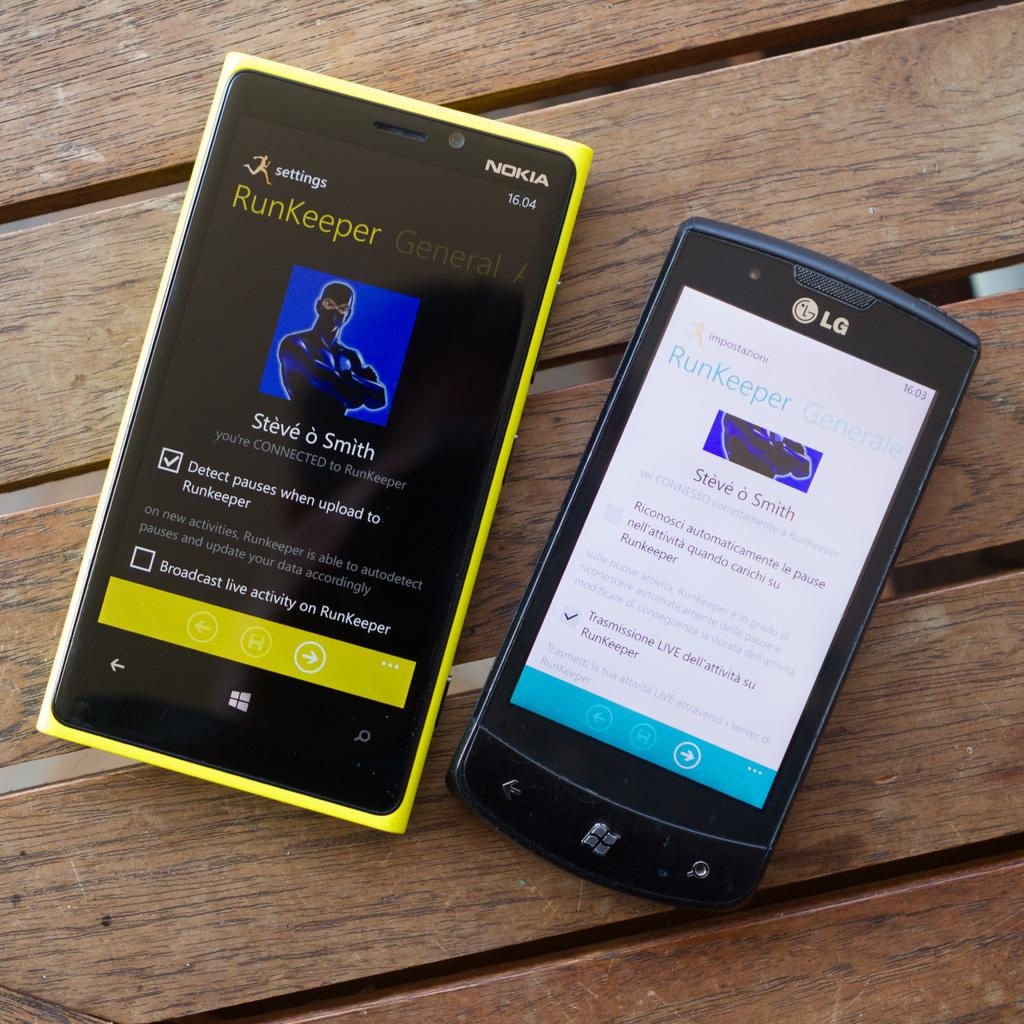<image>
Provide a brief description of the given image. yellow nokia phone next to smaller lg phone on a wooden surface 